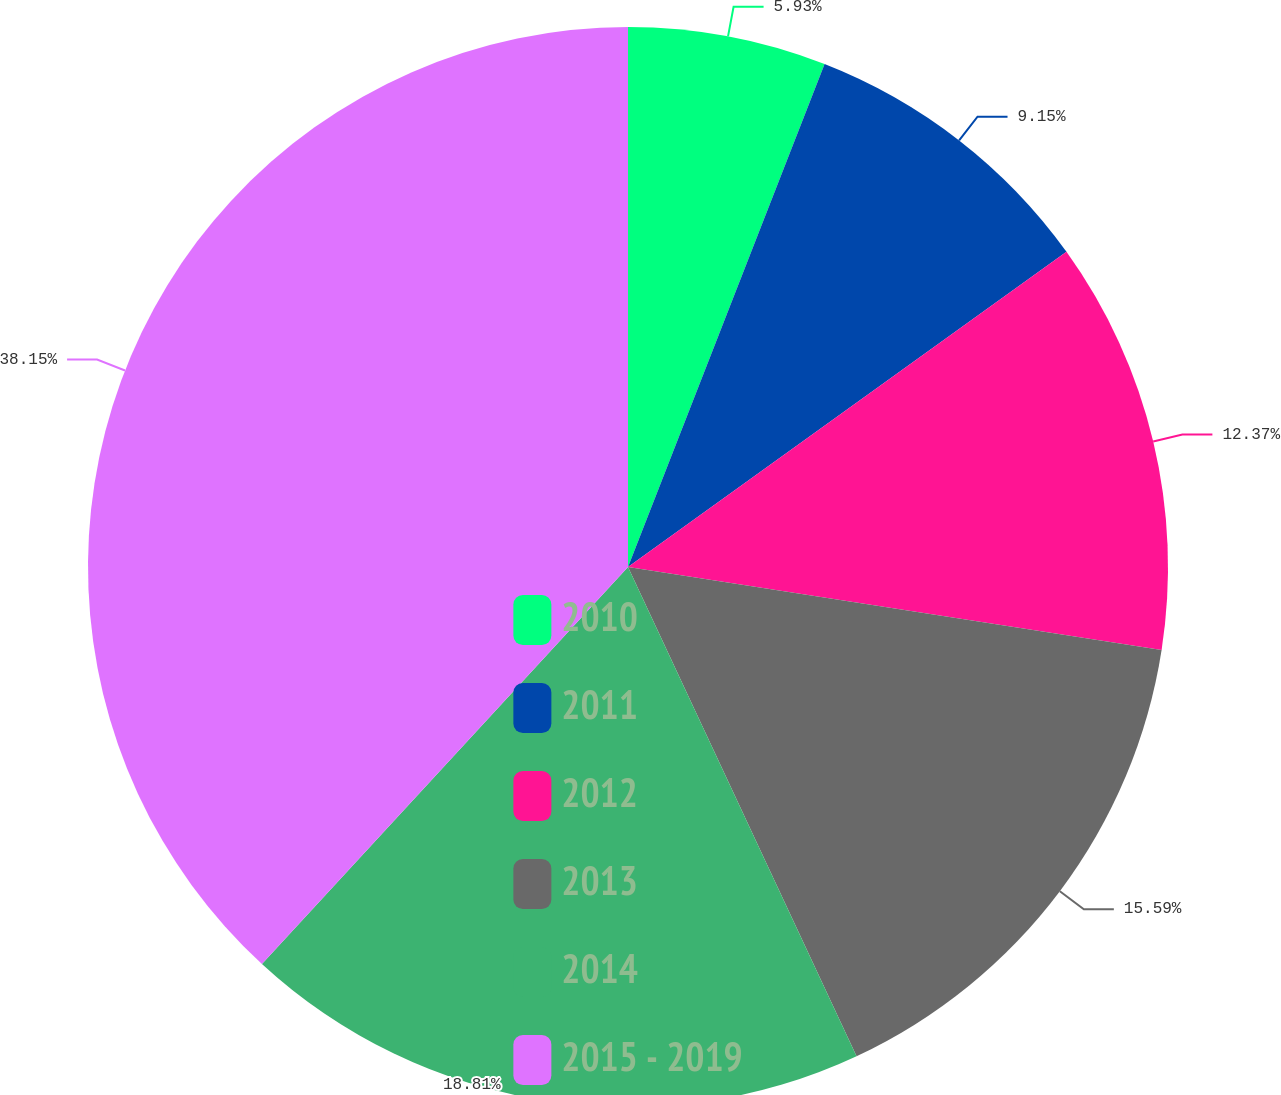<chart> <loc_0><loc_0><loc_500><loc_500><pie_chart><fcel>2010<fcel>2011<fcel>2012<fcel>2013<fcel>2014<fcel>2015 - 2019<nl><fcel>5.93%<fcel>9.15%<fcel>12.37%<fcel>15.59%<fcel>18.81%<fcel>38.14%<nl></chart> 